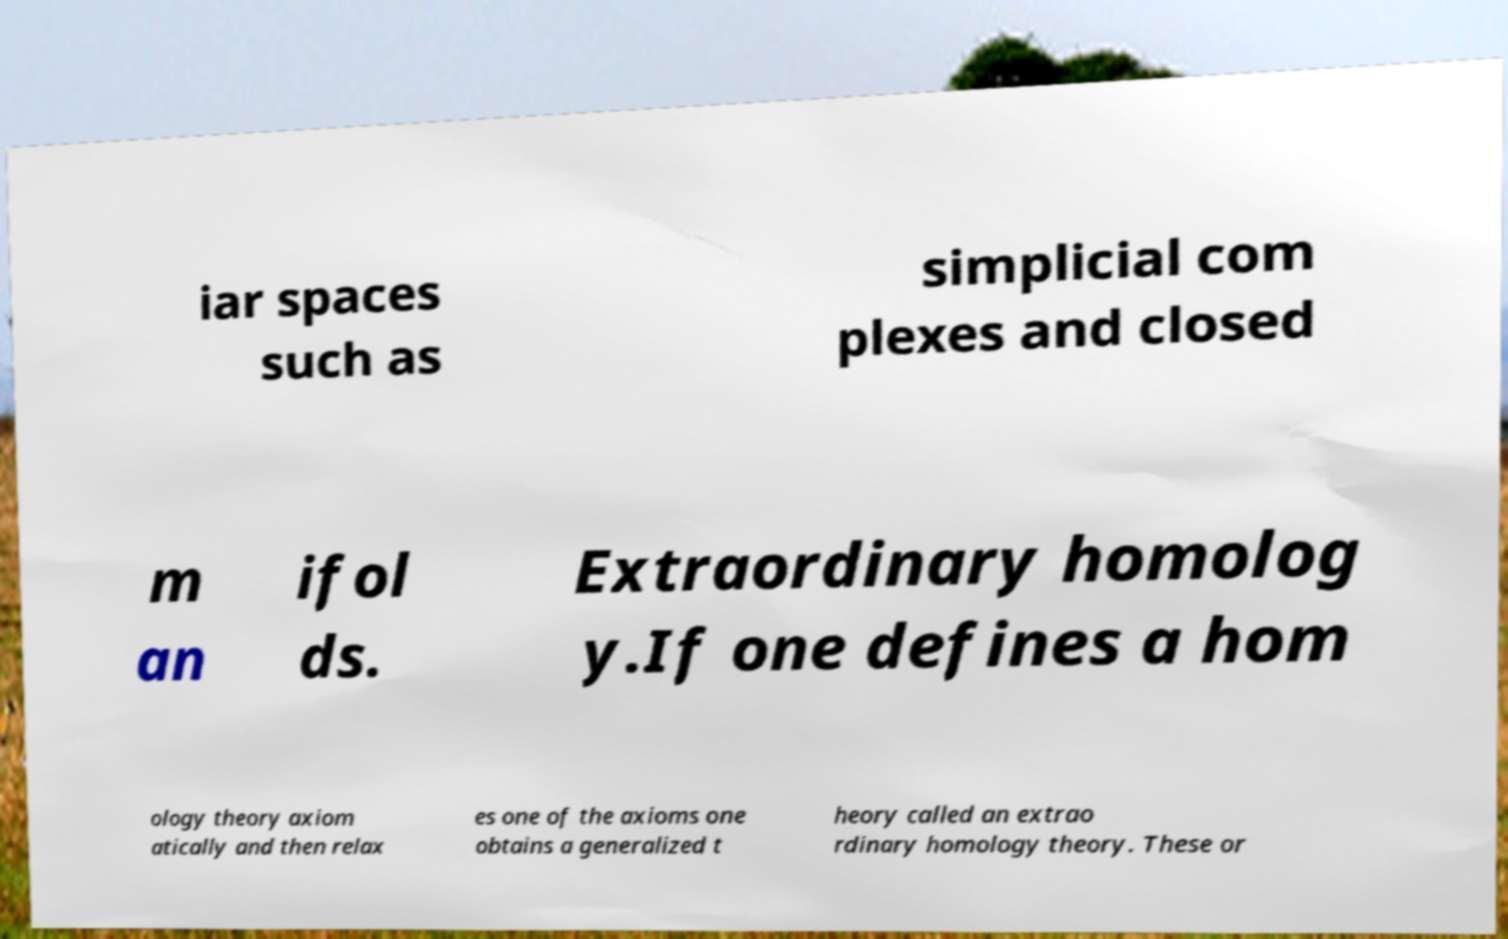Please read and relay the text visible in this image. What does it say? iar spaces such as simplicial com plexes and closed m an ifol ds. Extraordinary homolog y.If one defines a hom ology theory axiom atically and then relax es one of the axioms one obtains a generalized t heory called an extrao rdinary homology theory. These or 